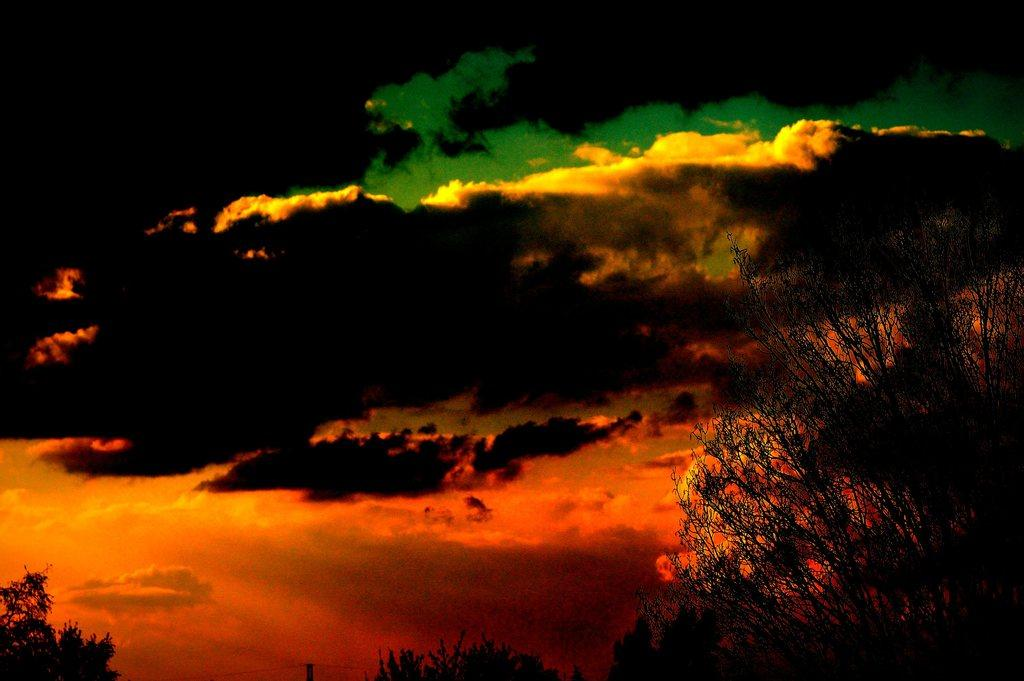What type of living organisms can be seen in the image? Plants can be seen in the image. What part of the natural environment is visible in the image? The sky is visible in the image. What colors are the clouds in the sky? The clouds in the sky have red, yellow, green, and black colors. How many pizzas are being served in the image? There are no pizzas present in the image. 